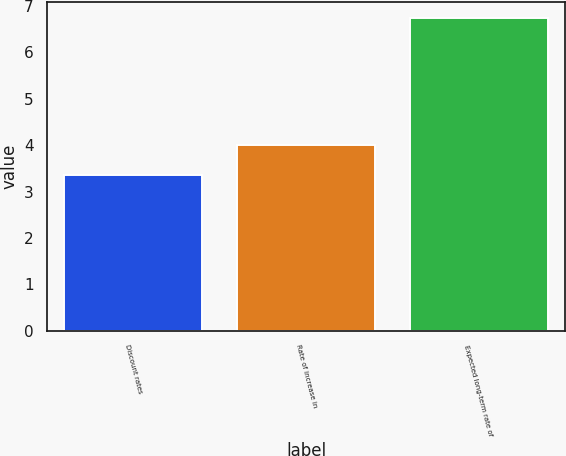<chart> <loc_0><loc_0><loc_500><loc_500><bar_chart><fcel>Discount rates<fcel>Rate of increase in<fcel>Expected long-term rate of<nl><fcel>3.36<fcel>4<fcel>6.75<nl></chart> 